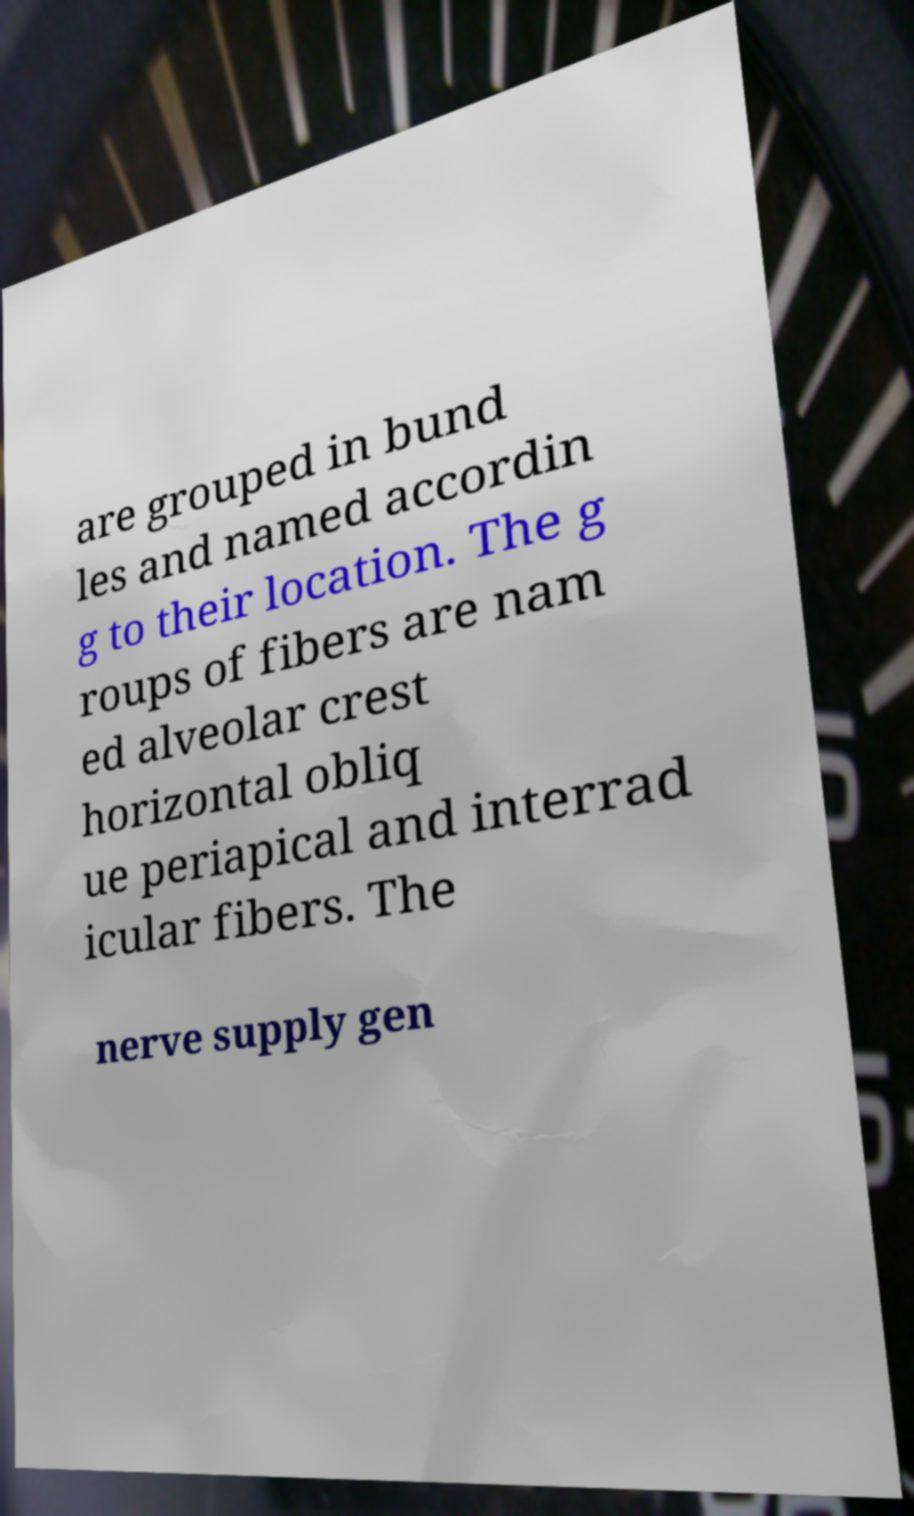Could you extract and type out the text from this image? are grouped in bund les and named accordin g to their location. The g roups of fibers are nam ed alveolar crest horizontal obliq ue periapical and interrad icular fibers. The nerve supply gen 